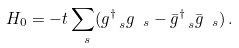<formula> <loc_0><loc_0><loc_500><loc_500>H _ { 0 } = - t \sum _ { \ s } ( g ^ { \dag } _ { \ s } g _ { \ s } - \bar { g } ^ { \dag } _ { \ s } \bar { g } _ { \ s } ) \, .</formula> 